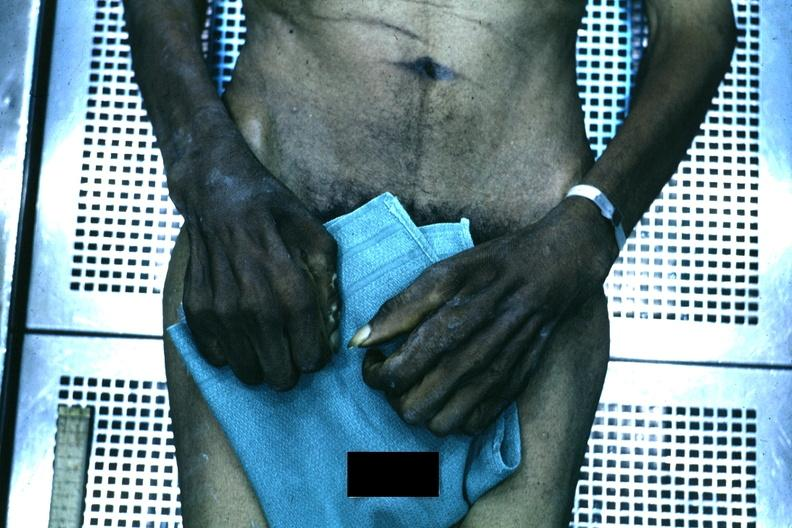s wound said to be due to syringomyelia?
Answer the question using a single word or phrase. No 